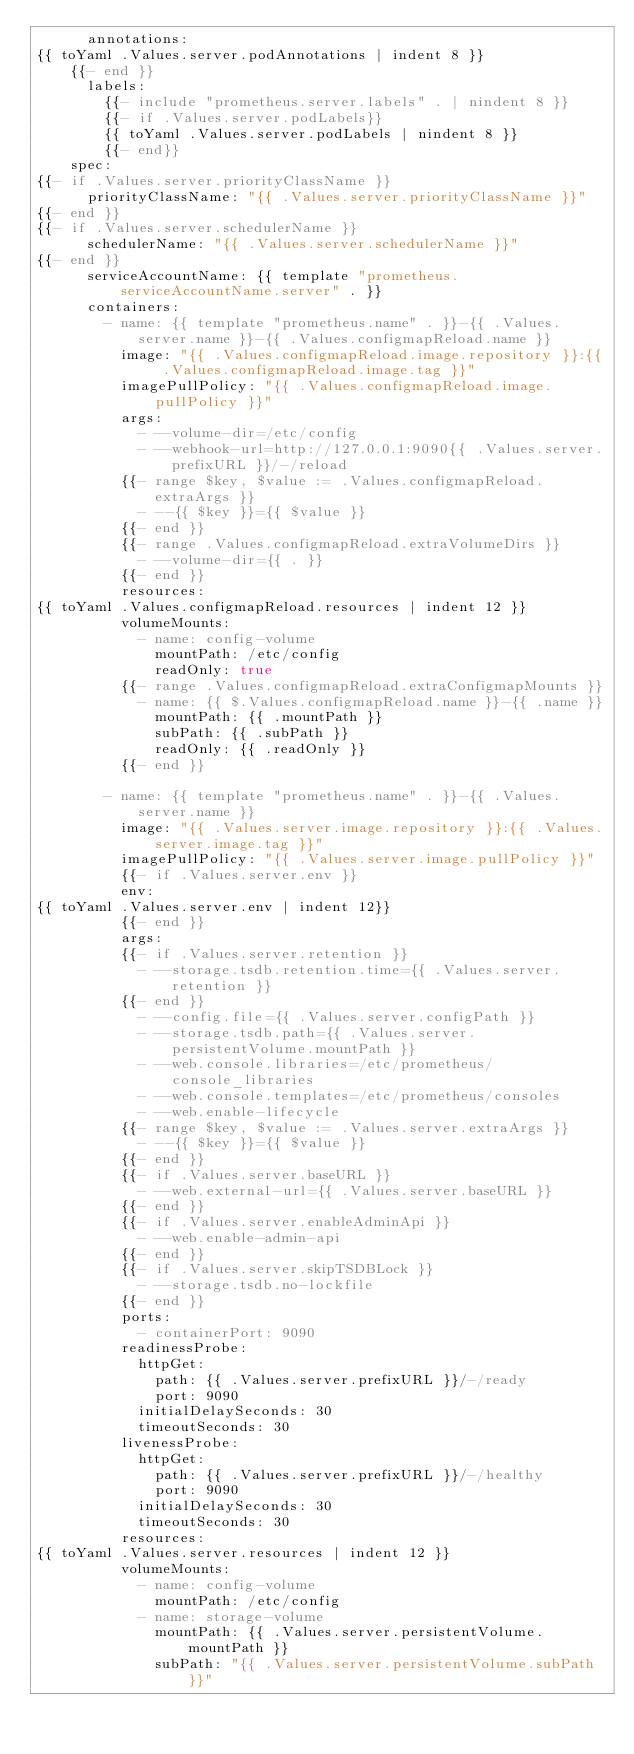Convert code to text. <code><loc_0><loc_0><loc_500><loc_500><_YAML_>      annotations:
{{ toYaml .Values.server.podAnnotations | indent 8 }}
    {{- end }}
      labels:
        {{- include "prometheus.server.labels" . | nindent 8 }}
        {{- if .Values.server.podLabels}}
        {{ toYaml .Values.server.podLabels | nindent 8 }}
        {{- end}}
    spec:
{{- if .Values.server.priorityClassName }}
      priorityClassName: "{{ .Values.server.priorityClassName }}"
{{- end }}
{{- if .Values.server.schedulerName }}
      schedulerName: "{{ .Values.server.schedulerName }}"
{{- end }}
      serviceAccountName: {{ template "prometheus.serviceAccountName.server" . }}
      containers:
        - name: {{ template "prometheus.name" . }}-{{ .Values.server.name }}-{{ .Values.configmapReload.name }}
          image: "{{ .Values.configmapReload.image.repository }}:{{ .Values.configmapReload.image.tag }}"
          imagePullPolicy: "{{ .Values.configmapReload.image.pullPolicy }}"
          args:
            - --volume-dir=/etc/config
            - --webhook-url=http://127.0.0.1:9090{{ .Values.server.prefixURL }}/-/reload
          {{- range $key, $value := .Values.configmapReload.extraArgs }}
            - --{{ $key }}={{ $value }}
          {{- end }}
          {{- range .Values.configmapReload.extraVolumeDirs }}
            - --volume-dir={{ . }}
          {{- end }}
          resources:
{{ toYaml .Values.configmapReload.resources | indent 12 }}
          volumeMounts:
            - name: config-volume
              mountPath: /etc/config
              readOnly: true
          {{- range .Values.configmapReload.extraConfigmapMounts }}
            - name: {{ $.Values.configmapReload.name }}-{{ .name }}
              mountPath: {{ .mountPath }}
              subPath: {{ .subPath }}
              readOnly: {{ .readOnly }}
          {{- end }}

        - name: {{ template "prometheus.name" . }}-{{ .Values.server.name }}
          image: "{{ .Values.server.image.repository }}:{{ .Values.server.image.tag }}"
          imagePullPolicy: "{{ .Values.server.image.pullPolicy }}"
          {{- if .Values.server.env }}
          env:
{{ toYaml .Values.server.env | indent 12}}
          {{- end }}
          args:
          {{- if .Values.server.retention }}
            - --storage.tsdb.retention.time={{ .Values.server.retention }}
          {{- end }}
            - --config.file={{ .Values.server.configPath }}
            - --storage.tsdb.path={{ .Values.server.persistentVolume.mountPath }}
            - --web.console.libraries=/etc/prometheus/console_libraries
            - --web.console.templates=/etc/prometheus/consoles
            - --web.enable-lifecycle
          {{- range $key, $value := .Values.server.extraArgs }}
            - --{{ $key }}={{ $value }}
          {{- end }}
          {{- if .Values.server.baseURL }}
            - --web.external-url={{ .Values.server.baseURL }}
          {{- end }}
          {{- if .Values.server.enableAdminApi }}
            - --web.enable-admin-api
          {{- end }}
          {{- if .Values.server.skipTSDBLock }}
            - --storage.tsdb.no-lockfile
          {{- end }}
          ports:
            - containerPort: 9090
          readinessProbe:
            httpGet:
              path: {{ .Values.server.prefixURL }}/-/ready
              port: 9090
            initialDelaySeconds: 30
            timeoutSeconds: 30
          livenessProbe:
            httpGet:
              path: {{ .Values.server.prefixURL }}/-/healthy
              port: 9090
            initialDelaySeconds: 30
            timeoutSeconds: 30
          resources:
{{ toYaml .Values.server.resources | indent 12 }}
          volumeMounts:
            - name: config-volume
              mountPath: /etc/config
            - name: storage-volume
              mountPath: {{ .Values.server.persistentVolume.mountPath }}
              subPath: "{{ .Values.server.persistentVolume.subPath }}"</code> 